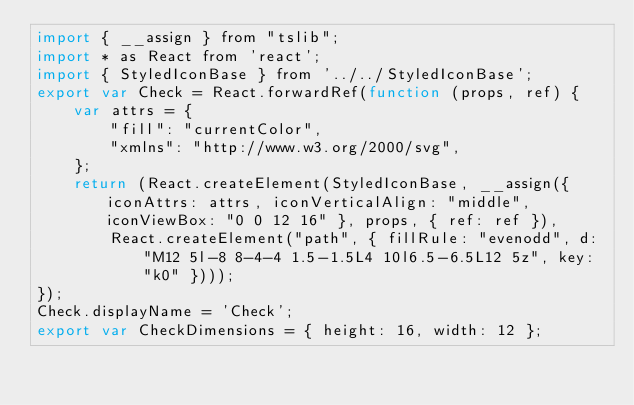Convert code to text. <code><loc_0><loc_0><loc_500><loc_500><_JavaScript_>import { __assign } from "tslib";
import * as React from 'react';
import { StyledIconBase } from '../../StyledIconBase';
export var Check = React.forwardRef(function (props, ref) {
    var attrs = {
        "fill": "currentColor",
        "xmlns": "http://www.w3.org/2000/svg",
    };
    return (React.createElement(StyledIconBase, __assign({ iconAttrs: attrs, iconVerticalAlign: "middle", iconViewBox: "0 0 12 16" }, props, { ref: ref }),
        React.createElement("path", { fillRule: "evenodd", d: "M12 5l-8 8-4-4 1.5-1.5L4 10l6.5-6.5L12 5z", key: "k0" })));
});
Check.displayName = 'Check';
export var CheckDimensions = { height: 16, width: 12 };
</code> 